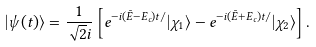Convert formula to latex. <formula><loc_0><loc_0><loc_500><loc_500>| \psi ( t ) \rangle = \frac { 1 } { \sqrt { 2 } i } \left [ e ^ { - i ( \bar { E } - E _ { c } ) t / } | \chi _ { 1 } \rangle - e ^ { - i ( \bar { E } + E _ { c } ) t / } | \chi _ { 2 } \rangle \right ] .</formula> 